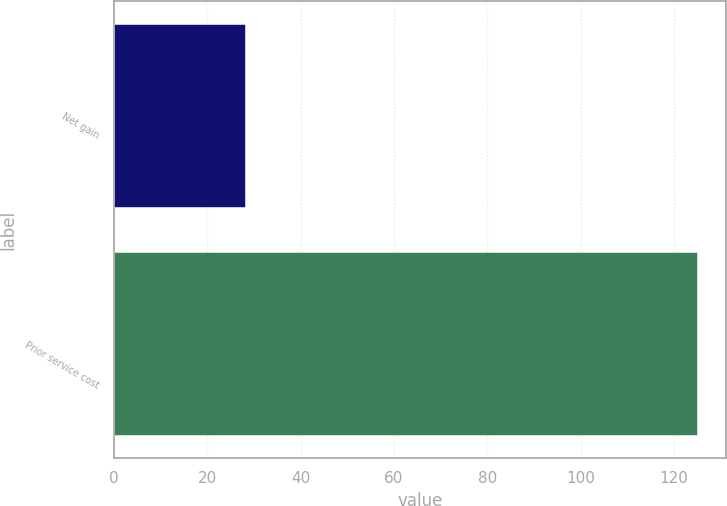Convert chart to OTSL. <chart><loc_0><loc_0><loc_500><loc_500><bar_chart><fcel>Net gain<fcel>Prior service cost<nl><fcel>28<fcel>125<nl></chart> 